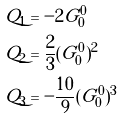Convert formula to latex. <formula><loc_0><loc_0><loc_500><loc_500>Q _ { 1 } & = - 2 G ^ { 0 } _ { 0 } \\ Q _ { 2 } & = \frac { 2 } { 3 } ( G ^ { 0 } _ { 0 } ) ^ { 2 } \\ Q _ { 3 } & = - \frac { 1 0 } { 9 } ( G ^ { 0 } _ { 0 } ) ^ { 3 }</formula> 